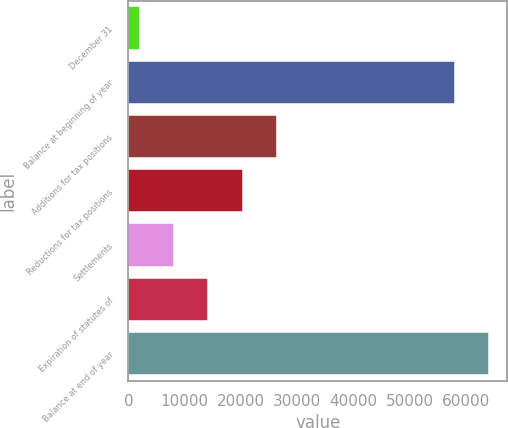<chart> <loc_0><loc_0><loc_500><loc_500><bar_chart><fcel>December 31<fcel>Balance at beginning of year<fcel>Additions for tax positions<fcel>Reductions for tax positions<fcel>Settlements<fcel>Expiration of statutes of<fcel>Balance at end of year<nl><fcel>2009<fcel>58000<fcel>26407.4<fcel>20307.8<fcel>8108.6<fcel>14208.2<fcel>64099.6<nl></chart> 